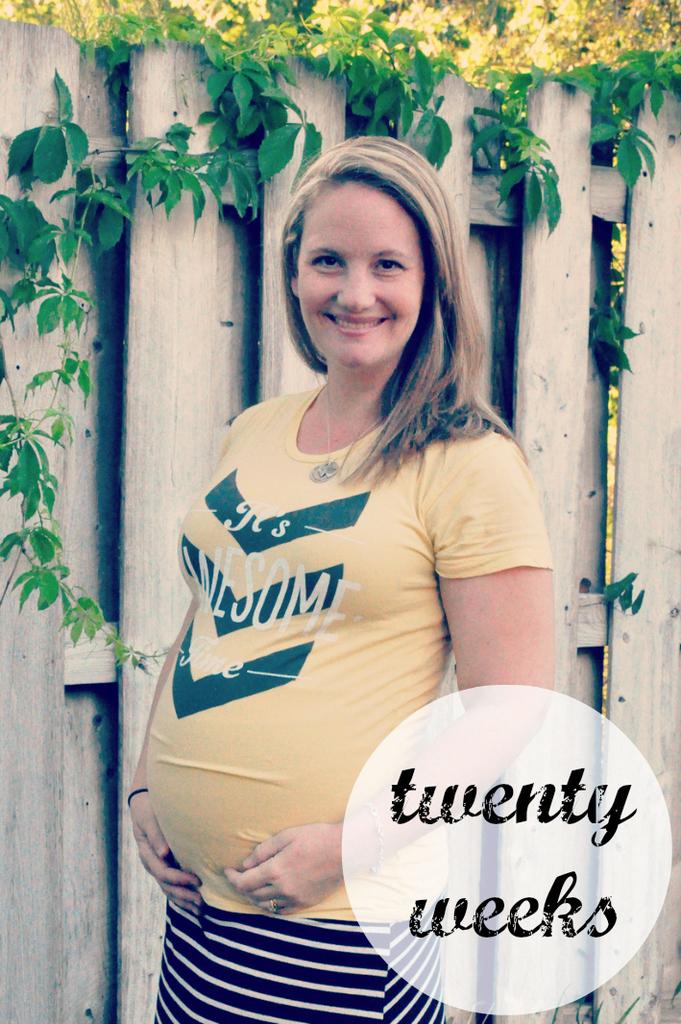How many weeks along is this pregnant woman?
Make the answer very short. Twenty. What does her shirt say?
Your answer should be compact. It's awesome time. 